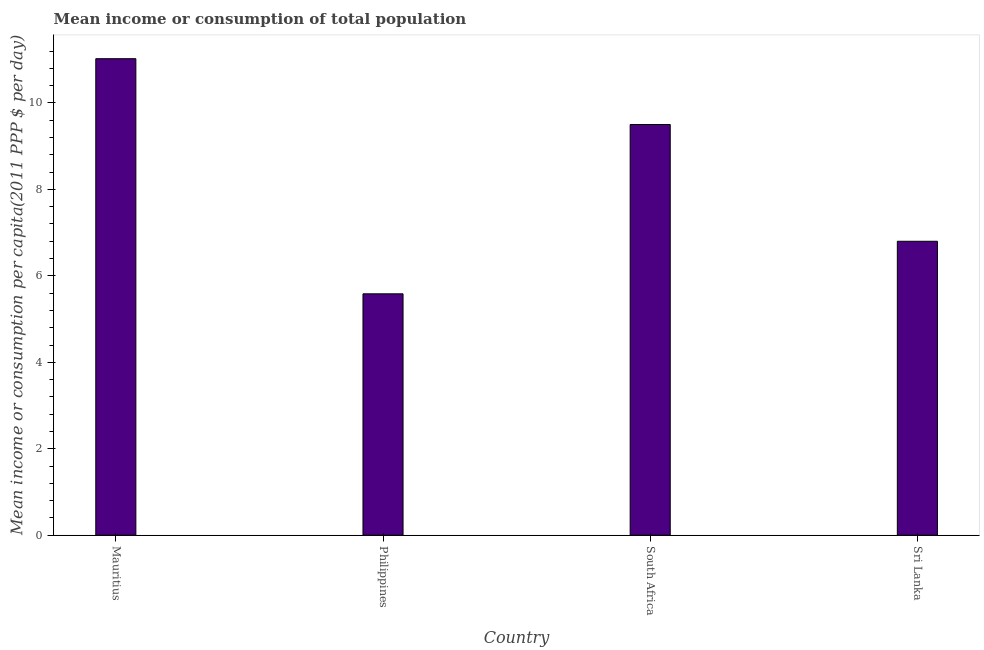What is the title of the graph?
Your answer should be compact. Mean income or consumption of total population. What is the label or title of the X-axis?
Your answer should be very brief. Country. What is the label or title of the Y-axis?
Provide a succinct answer. Mean income or consumption per capita(2011 PPP $ per day). What is the mean income or consumption in Philippines?
Offer a terse response. 5.58. Across all countries, what is the maximum mean income or consumption?
Your answer should be compact. 11.02. Across all countries, what is the minimum mean income or consumption?
Your response must be concise. 5.58. In which country was the mean income or consumption maximum?
Give a very brief answer. Mauritius. What is the sum of the mean income or consumption?
Keep it short and to the point. 32.91. What is the difference between the mean income or consumption in South Africa and Sri Lanka?
Keep it short and to the point. 2.7. What is the average mean income or consumption per country?
Your response must be concise. 8.23. What is the median mean income or consumption?
Make the answer very short. 8.15. In how many countries, is the mean income or consumption greater than 9.6 $?
Offer a terse response. 1. What is the ratio of the mean income or consumption in Philippines to that in South Africa?
Your answer should be compact. 0.59. What is the difference between the highest and the second highest mean income or consumption?
Give a very brief answer. 1.52. Is the sum of the mean income or consumption in Mauritius and South Africa greater than the maximum mean income or consumption across all countries?
Offer a very short reply. Yes. What is the difference between the highest and the lowest mean income or consumption?
Make the answer very short. 5.44. In how many countries, is the mean income or consumption greater than the average mean income or consumption taken over all countries?
Offer a very short reply. 2. What is the Mean income or consumption per capita(2011 PPP $ per day) in Mauritius?
Provide a succinct answer. 11.02. What is the Mean income or consumption per capita(2011 PPP $ per day) of Philippines?
Offer a terse response. 5.58. What is the Mean income or consumption per capita(2011 PPP $ per day) in Sri Lanka?
Provide a short and direct response. 6.8. What is the difference between the Mean income or consumption per capita(2011 PPP $ per day) in Mauritius and Philippines?
Keep it short and to the point. 5.44. What is the difference between the Mean income or consumption per capita(2011 PPP $ per day) in Mauritius and South Africa?
Your answer should be very brief. 1.52. What is the difference between the Mean income or consumption per capita(2011 PPP $ per day) in Mauritius and Sri Lanka?
Your response must be concise. 4.22. What is the difference between the Mean income or consumption per capita(2011 PPP $ per day) in Philippines and South Africa?
Your answer should be very brief. -3.92. What is the difference between the Mean income or consumption per capita(2011 PPP $ per day) in Philippines and Sri Lanka?
Provide a succinct answer. -1.22. What is the difference between the Mean income or consumption per capita(2011 PPP $ per day) in South Africa and Sri Lanka?
Ensure brevity in your answer.  2.7. What is the ratio of the Mean income or consumption per capita(2011 PPP $ per day) in Mauritius to that in Philippines?
Make the answer very short. 1.97. What is the ratio of the Mean income or consumption per capita(2011 PPP $ per day) in Mauritius to that in South Africa?
Your answer should be very brief. 1.16. What is the ratio of the Mean income or consumption per capita(2011 PPP $ per day) in Mauritius to that in Sri Lanka?
Offer a terse response. 1.62. What is the ratio of the Mean income or consumption per capita(2011 PPP $ per day) in Philippines to that in South Africa?
Your answer should be compact. 0.59. What is the ratio of the Mean income or consumption per capita(2011 PPP $ per day) in Philippines to that in Sri Lanka?
Ensure brevity in your answer.  0.82. What is the ratio of the Mean income or consumption per capita(2011 PPP $ per day) in South Africa to that in Sri Lanka?
Provide a short and direct response. 1.4. 